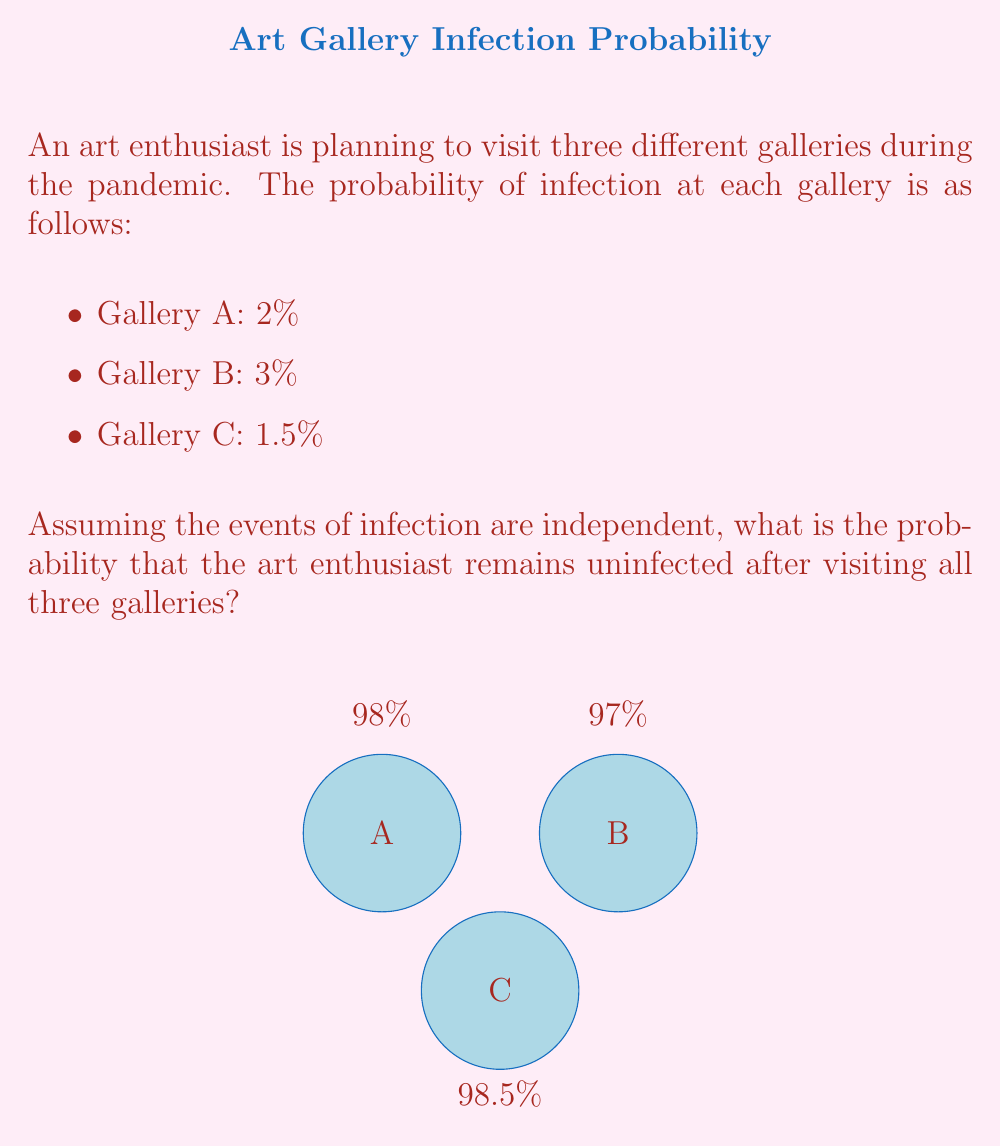Help me with this question. Let's approach this step-by-step:

1) First, we need to calculate the probability of not getting infected at each gallery:
   - Gallery A: $1 - 0.02 = 0.98$ or 98%
   - Gallery B: $1 - 0.03 = 0.97$ or 97%
   - Gallery C: $1 - 0.015 = 0.985$ or 98.5%

2) Since we want the probability of remaining uninfected after visiting all three galleries, and the events are independent, we need to multiply these probabilities:

   $$P(\text{uninfected}) = 0.98 \times 0.97 \times 0.985$$

3) Let's calculate this:
   $$P(\text{uninfected}) = 0.98 \times 0.97 \times 0.985 = 0.93573$$

4) To convert to a percentage, we multiply by 100:
   $$0.93573 \times 100 = 93.573\%$$

Therefore, the probability that the art enthusiast remains uninfected after visiting all three galleries is approximately 93.573% or about 93.57%.
Answer: $93.57\%$ 